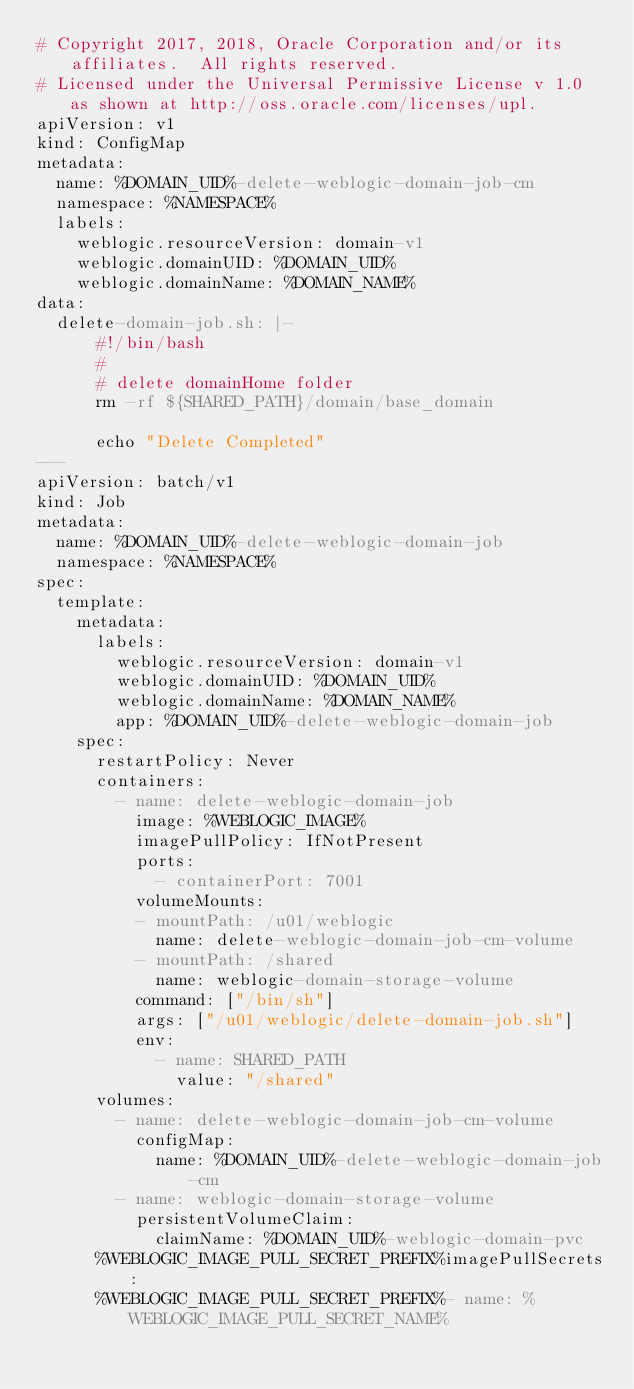<code> <loc_0><loc_0><loc_500><loc_500><_YAML_># Copyright 2017, 2018, Oracle Corporation and/or its affiliates.  All rights reserved.
# Licensed under the Universal Permissive License v 1.0 as shown at http://oss.oracle.com/licenses/upl.
apiVersion: v1
kind: ConfigMap
metadata:
  name: %DOMAIN_UID%-delete-weblogic-domain-job-cm
  namespace: %NAMESPACE%
  labels:
    weblogic.resourceVersion: domain-v1
    weblogic.domainUID: %DOMAIN_UID%
    weblogic.domainName: %DOMAIN_NAME%
data:
  delete-domain-job.sh: |-
      #!/bin/bash
      #
      # delete domainHome folder
      rm -rf ${SHARED_PATH}/domain/base_domain

      echo "Delete Completed"
---
apiVersion: batch/v1
kind: Job
metadata:
  name: %DOMAIN_UID%-delete-weblogic-domain-job
  namespace: %NAMESPACE%
spec:
  template:
    metadata:
      labels:
        weblogic.resourceVersion: domain-v1
        weblogic.domainUID: %DOMAIN_UID%
        weblogic.domainName: %DOMAIN_NAME%
        app: %DOMAIN_UID%-delete-weblogic-domain-job
    spec:
      restartPolicy: Never
      containers:
        - name: delete-weblogic-domain-job
          image: %WEBLOGIC_IMAGE%
          imagePullPolicy: IfNotPresent
          ports:
            - containerPort: 7001
          volumeMounts:
          - mountPath: /u01/weblogic
            name: delete-weblogic-domain-job-cm-volume
          - mountPath: /shared
            name: weblogic-domain-storage-volume
          command: ["/bin/sh"]
          args: ["/u01/weblogic/delete-domain-job.sh"]
          env:
            - name: SHARED_PATH
              value: "/shared"
      volumes:
        - name: delete-weblogic-domain-job-cm-volume
          configMap:
            name: %DOMAIN_UID%-delete-weblogic-domain-job-cm
        - name: weblogic-domain-storage-volume
          persistentVolumeClaim:
            claimName: %DOMAIN_UID%-weblogic-domain-pvc
      %WEBLOGIC_IMAGE_PULL_SECRET_PREFIX%imagePullSecrets:
      %WEBLOGIC_IMAGE_PULL_SECRET_PREFIX%- name: %WEBLOGIC_IMAGE_PULL_SECRET_NAME%
</code> 